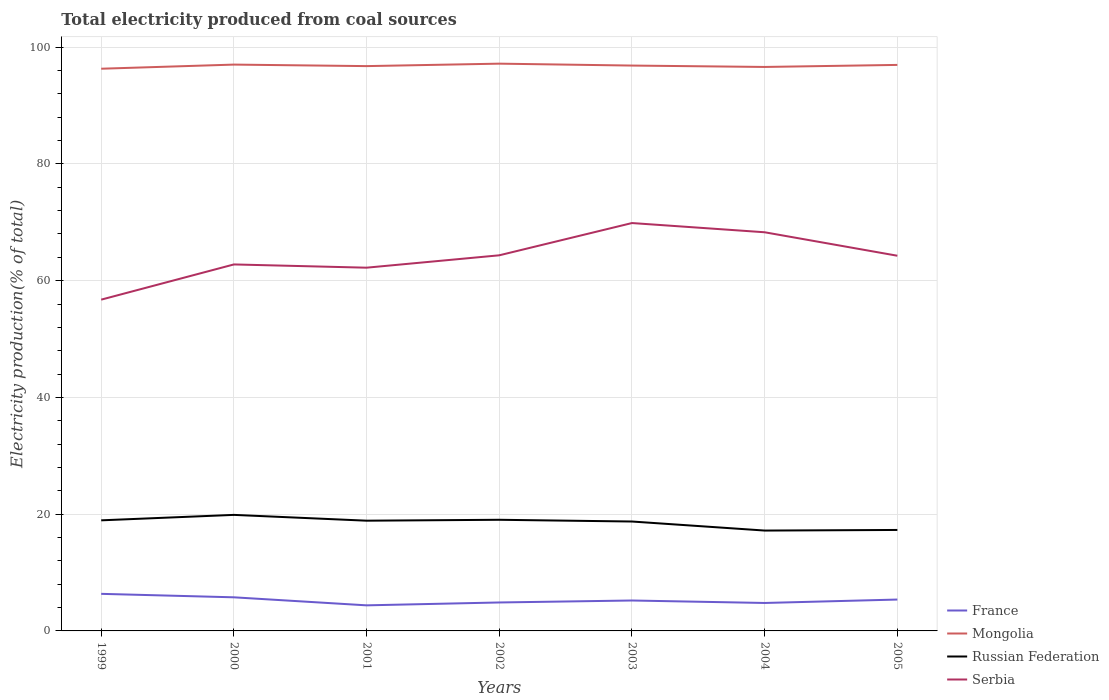How many different coloured lines are there?
Your response must be concise. 4. Does the line corresponding to Mongolia intersect with the line corresponding to Russian Federation?
Make the answer very short. No. Is the number of lines equal to the number of legend labels?
Provide a short and direct response. Yes. Across all years, what is the maximum total electricity produced in Serbia?
Offer a terse response. 56.75. What is the total total electricity produced in France in the graph?
Give a very brief answer. -0.41. What is the difference between the highest and the second highest total electricity produced in Serbia?
Your answer should be very brief. 13.12. How many lines are there?
Offer a very short reply. 4. How many years are there in the graph?
Provide a short and direct response. 7. Does the graph contain any zero values?
Your answer should be very brief. No. How many legend labels are there?
Make the answer very short. 4. What is the title of the graph?
Offer a very short reply. Total electricity produced from coal sources. What is the label or title of the X-axis?
Make the answer very short. Years. What is the label or title of the Y-axis?
Provide a succinct answer. Electricity production(% of total). What is the Electricity production(% of total) in France in 1999?
Give a very brief answer. 6.35. What is the Electricity production(% of total) of Mongolia in 1999?
Your answer should be very brief. 96.31. What is the Electricity production(% of total) of Russian Federation in 1999?
Make the answer very short. 18.94. What is the Electricity production(% of total) of Serbia in 1999?
Ensure brevity in your answer.  56.75. What is the Electricity production(% of total) of France in 2000?
Your answer should be very brief. 5.76. What is the Electricity production(% of total) of Mongolia in 2000?
Provide a succinct answer. 97.01. What is the Electricity production(% of total) of Russian Federation in 2000?
Ensure brevity in your answer.  19.88. What is the Electricity production(% of total) in Serbia in 2000?
Your answer should be compact. 62.78. What is the Electricity production(% of total) of France in 2001?
Offer a very short reply. 4.38. What is the Electricity production(% of total) in Mongolia in 2001?
Your answer should be compact. 96.75. What is the Electricity production(% of total) of Russian Federation in 2001?
Your answer should be very brief. 18.88. What is the Electricity production(% of total) in Serbia in 2001?
Provide a succinct answer. 62.22. What is the Electricity production(% of total) in France in 2002?
Ensure brevity in your answer.  4.87. What is the Electricity production(% of total) of Mongolia in 2002?
Keep it short and to the point. 97.17. What is the Electricity production(% of total) of Russian Federation in 2002?
Give a very brief answer. 19.04. What is the Electricity production(% of total) in Serbia in 2002?
Ensure brevity in your answer.  64.34. What is the Electricity production(% of total) of France in 2003?
Offer a terse response. 5.21. What is the Electricity production(% of total) in Mongolia in 2003?
Give a very brief answer. 96.85. What is the Electricity production(% of total) of Russian Federation in 2003?
Provide a succinct answer. 18.74. What is the Electricity production(% of total) of Serbia in 2003?
Give a very brief answer. 69.87. What is the Electricity production(% of total) of France in 2004?
Ensure brevity in your answer.  4.79. What is the Electricity production(% of total) of Mongolia in 2004?
Make the answer very short. 96.61. What is the Electricity production(% of total) of Russian Federation in 2004?
Give a very brief answer. 17.19. What is the Electricity production(% of total) in Serbia in 2004?
Provide a short and direct response. 68.29. What is the Electricity production(% of total) of France in 2005?
Your answer should be very brief. 5.37. What is the Electricity production(% of total) of Mongolia in 2005?
Offer a very short reply. 96.96. What is the Electricity production(% of total) in Russian Federation in 2005?
Your answer should be very brief. 17.3. What is the Electricity production(% of total) of Serbia in 2005?
Keep it short and to the point. 64.27. Across all years, what is the maximum Electricity production(% of total) in France?
Offer a very short reply. 6.35. Across all years, what is the maximum Electricity production(% of total) in Mongolia?
Give a very brief answer. 97.17. Across all years, what is the maximum Electricity production(% of total) in Russian Federation?
Offer a very short reply. 19.88. Across all years, what is the maximum Electricity production(% of total) of Serbia?
Offer a very short reply. 69.87. Across all years, what is the minimum Electricity production(% of total) in France?
Give a very brief answer. 4.38. Across all years, what is the minimum Electricity production(% of total) of Mongolia?
Keep it short and to the point. 96.31. Across all years, what is the minimum Electricity production(% of total) in Russian Federation?
Keep it short and to the point. 17.19. Across all years, what is the minimum Electricity production(% of total) of Serbia?
Give a very brief answer. 56.75. What is the total Electricity production(% of total) in France in the graph?
Give a very brief answer. 36.74. What is the total Electricity production(% of total) in Mongolia in the graph?
Keep it short and to the point. 677.65. What is the total Electricity production(% of total) of Russian Federation in the graph?
Your response must be concise. 129.97. What is the total Electricity production(% of total) of Serbia in the graph?
Your response must be concise. 448.53. What is the difference between the Electricity production(% of total) of France in 1999 and that in 2000?
Provide a short and direct response. 0.59. What is the difference between the Electricity production(% of total) of Mongolia in 1999 and that in 2000?
Offer a terse response. -0.71. What is the difference between the Electricity production(% of total) in Russian Federation in 1999 and that in 2000?
Offer a terse response. -0.93. What is the difference between the Electricity production(% of total) of Serbia in 1999 and that in 2000?
Ensure brevity in your answer.  -6.03. What is the difference between the Electricity production(% of total) of France in 1999 and that in 2001?
Keep it short and to the point. 1.97. What is the difference between the Electricity production(% of total) of Mongolia in 1999 and that in 2001?
Provide a succinct answer. -0.45. What is the difference between the Electricity production(% of total) of Russian Federation in 1999 and that in 2001?
Your answer should be compact. 0.06. What is the difference between the Electricity production(% of total) of Serbia in 1999 and that in 2001?
Your response must be concise. -5.47. What is the difference between the Electricity production(% of total) of France in 1999 and that in 2002?
Provide a succinct answer. 1.48. What is the difference between the Electricity production(% of total) of Mongolia in 1999 and that in 2002?
Ensure brevity in your answer.  -0.87. What is the difference between the Electricity production(% of total) of Russian Federation in 1999 and that in 2002?
Your answer should be compact. -0.09. What is the difference between the Electricity production(% of total) in Serbia in 1999 and that in 2002?
Your answer should be very brief. -7.59. What is the difference between the Electricity production(% of total) of France in 1999 and that in 2003?
Provide a short and direct response. 1.14. What is the difference between the Electricity production(% of total) in Mongolia in 1999 and that in 2003?
Your answer should be very brief. -0.54. What is the difference between the Electricity production(% of total) of Russian Federation in 1999 and that in 2003?
Provide a short and direct response. 0.2. What is the difference between the Electricity production(% of total) in Serbia in 1999 and that in 2003?
Offer a terse response. -13.12. What is the difference between the Electricity production(% of total) of France in 1999 and that in 2004?
Ensure brevity in your answer.  1.57. What is the difference between the Electricity production(% of total) in Mongolia in 1999 and that in 2004?
Provide a short and direct response. -0.3. What is the difference between the Electricity production(% of total) in Russian Federation in 1999 and that in 2004?
Your answer should be compact. 1.75. What is the difference between the Electricity production(% of total) of Serbia in 1999 and that in 2004?
Give a very brief answer. -11.54. What is the difference between the Electricity production(% of total) of France in 1999 and that in 2005?
Offer a terse response. 0.98. What is the difference between the Electricity production(% of total) of Mongolia in 1999 and that in 2005?
Offer a terse response. -0.65. What is the difference between the Electricity production(% of total) in Russian Federation in 1999 and that in 2005?
Offer a very short reply. 1.65. What is the difference between the Electricity production(% of total) in Serbia in 1999 and that in 2005?
Your answer should be compact. -7.52. What is the difference between the Electricity production(% of total) of France in 2000 and that in 2001?
Make the answer very short. 1.38. What is the difference between the Electricity production(% of total) of Mongolia in 2000 and that in 2001?
Offer a terse response. 0.26. What is the difference between the Electricity production(% of total) in Russian Federation in 2000 and that in 2001?
Your answer should be very brief. 1. What is the difference between the Electricity production(% of total) of Serbia in 2000 and that in 2001?
Provide a short and direct response. 0.56. What is the difference between the Electricity production(% of total) of France in 2000 and that in 2002?
Make the answer very short. 0.88. What is the difference between the Electricity production(% of total) of Mongolia in 2000 and that in 2002?
Keep it short and to the point. -0.16. What is the difference between the Electricity production(% of total) in Russian Federation in 2000 and that in 2002?
Your response must be concise. 0.84. What is the difference between the Electricity production(% of total) of Serbia in 2000 and that in 2002?
Offer a terse response. -1.56. What is the difference between the Electricity production(% of total) of France in 2000 and that in 2003?
Give a very brief answer. 0.55. What is the difference between the Electricity production(% of total) in Mongolia in 2000 and that in 2003?
Provide a succinct answer. 0.17. What is the difference between the Electricity production(% of total) of Russian Federation in 2000 and that in 2003?
Offer a very short reply. 1.14. What is the difference between the Electricity production(% of total) of Serbia in 2000 and that in 2003?
Offer a very short reply. -7.09. What is the difference between the Electricity production(% of total) of France in 2000 and that in 2004?
Your answer should be very brief. 0.97. What is the difference between the Electricity production(% of total) of Mongolia in 2000 and that in 2004?
Your answer should be compact. 0.4. What is the difference between the Electricity production(% of total) in Russian Federation in 2000 and that in 2004?
Keep it short and to the point. 2.68. What is the difference between the Electricity production(% of total) in Serbia in 2000 and that in 2004?
Provide a succinct answer. -5.51. What is the difference between the Electricity production(% of total) of France in 2000 and that in 2005?
Offer a terse response. 0.38. What is the difference between the Electricity production(% of total) of Mongolia in 2000 and that in 2005?
Keep it short and to the point. 0.05. What is the difference between the Electricity production(% of total) of Russian Federation in 2000 and that in 2005?
Make the answer very short. 2.58. What is the difference between the Electricity production(% of total) in Serbia in 2000 and that in 2005?
Your answer should be compact. -1.49. What is the difference between the Electricity production(% of total) in France in 2001 and that in 2002?
Your answer should be compact. -0.49. What is the difference between the Electricity production(% of total) in Mongolia in 2001 and that in 2002?
Give a very brief answer. -0.42. What is the difference between the Electricity production(% of total) of Russian Federation in 2001 and that in 2002?
Make the answer very short. -0.16. What is the difference between the Electricity production(% of total) of Serbia in 2001 and that in 2002?
Your answer should be compact. -2.12. What is the difference between the Electricity production(% of total) in France in 2001 and that in 2003?
Give a very brief answer. -0.83. What is the difference between the Electricity production(% of total) in Mongolia in 2001 and that in 2003?
Provide a succinct answer. -0.09. What is the difference between the Electricity production(% of total) in Russian Federation in 2001 and that in 2003?
Your answer should be very brief. 0.14. What is the difference between the Electricity production(% of total) in Serbia in 2001 and that in 2003?
Your answer should be compact. -7.65. What is the difference between the Electricity production(% of total) of France in 2001 and that in 2004?
Give a very brief answer. -0.41. What is the difference between the Electricity production(% of total) of Mongolia in 2001 and that in 2004?
Your answer should be very brief. 0.14. What is the difference between the Electricity production(% of total) of Russian Federation in 2001 and that in 2004?
Provide a succinct answer. 1.69. What is the difference between the Electricity production(% of total) in Serbia in 2001 and that in 2004?
Your response must be concise. -6.07. What is the difference between the Electricity production(% of total) of France in 2001 and that in 2005?
Give a very brief answer. -0.99. What is the difference between the Electricity production(% of total) in Mongolia in 2001 and that in 2005?
Your response must be concise. -0.21. What is the difference between the Electricity production(% of total) of Russian Federation in 2001 and that in 2005?
Offer a terse response. 1.59. What is the difference between the Electricity production(% of total) of Serbia in 2001 and that in 2005?
Provide a short and direct response. -2.05. What is the difference between the Electricity production(% of total) in France in 2002 and that in 2003?
Your response must be concise. -0.34. What is the difference between the Electricity production(% of total) in Mongolia in 2002 and that in 2003?
Provide a succinct answer. 0.33. What is the difference between the Electricity production(% of total) of Russian Federation in 2002 and that in 2003?
Your answer should be compact. 0.3. What is the difference between the Electricity production(% of total) of Serbia in 2002 and that in 2003?
Offer a very short reply. -5.53. What is the difference between the Electricity production(% of total) in France in 2002 and that in 2004?
Offer a terse response. 0.09. What is the difference between the Electricity production(% of total) in Mongolia in 2002 and that in 2004?
Offer a very short reply. 0.56. What is the difference between the Electricity production(% of total) of Russian Federation in 2002 and that in 2004?
Give a very brief answer. 1.85. What is the difference between the Electricity production(% of total) in Serbia in 2002 and that in 2004?
Offer a very short reply. -3.95. What is the difference between the Electricity production(% of total) of France in 2002 and that in 2005?
Give a very brief answer. -0.5. What is the difference between the Electricity production(% of total) in Mongolia in 2002 and that in 2005?
Ensure brevity in your answer.  0.21. What is the difference between the Electricity production(% of total) in Russian Federation in 2002 and that in 2005?
Ensure brevity in your answer.  1.74. What is the difference between the Electricity production(% of total) of Serbia in 2002 and that in 2005?
Provide a succinct answer. 0.07. What is the difference between the Electricity production(% of total) in France in 2003 and that in 2004?
Your answer should be very brief. 0.42. What is the difference between the Electricity production(% of total) of Mongolia in 2003 and that in 2004?
Your answer should be very brief. 0.24. What is the difference between the Electricity production(% of total) of Russian Federation in 2003 and that in 2004?
Your answer should be very brief. 1.55. What is the difference between the Electricity production(% of total) of Serbia in 2003 and that in 2004?
Keep it short and to the point. 1.58. What is the difference between the Electricity production(% of total) of France in 2003 and that in 2005?
Ensure brevity in your answer.  -0.16. What is the difference between the Electricity production(% of total) of Mongolia in 2003 and that in 2005?
Give a very brief answer. -0.11. What is the difference between the Electricity production(% of total) of Russian Federation in 2003 and that in 2005?
Provide a short and direct response. 1.45. What is the difference between the Electricity production(% of total) in Serbia in 2003 and that in 2005?
Offer a very short reply. 5.6. What is the difference between the Electricity production(% of total) in France in 2004 and that in 2005?
Provide a short and direct response. -0.59. What is the difference between the Electricity production(% of total) in Mongolia in 2004 and that in 2005?
Make the answer very short. -0.35. What is the difference between the Electricity production(% of total) in Russian Federation in 2004 and that in 2005?
Provide a succinct answer. -0.1. What is the difference between the Electricity production(% of total) in Serbia in 2004 and that in 2005?
Keep it short and to the point. 4.02. What is the difference between the Electricity production(% of total) of France in 1999 and the Electricity production(% of total) of Mongolia in 2000?
Offer a very short reply. -90.66. What is the difference between the Electricity production(% of total) of France in 1999 and the Electricity production(% of total) of Russian Federation in 2000?
Offer a terse response. -13.52. What is the difference between the Electricity production(% of total) of France in 1999 and the Electricity production(% of total) of Serbia in 2000?
Ensure brevity in your answer.  -56.43. What is the difference between the Electricity production(% of total) of Mongolia in 1999 and the Electricity production(% of total) of Russian Federation in 2000?
Give a very brief answer. 76.43. What is the difference between the Electricity production(% of total) of Mongolia in 1999 and the Electricity production(% of total) of Serbia in 2000?
Your response must be concise. 33.53. What is the difference between the Electricity production(% of total) of Russian Federation in 1999 and the Electricity production(% of total) of Serbia in 2000?
Keep it short and to the point. -43.84. What is the difference between the Electricity production(% of total) of France in 1999 and the Electricity production(% of total) of Mongolia in 2001?
Provide a succinct answer. -90.4. What is the difference between the Electricity production(% of total) in France in 1999 and the Electricity production(% of total) in Russian Federation in 2001?
Ensure brevity in your answer.  -12.53. What is the difference between the Electricity production(% of total) in France in 1999 and the Electricity production(% of total) in Serbia in 2001?
Offer a very short reply. -55.87. What is the difference between the Electricity production(% of total) of Mongolia in 1999 and the Electricity production(% of total) of Russian Federation in 2001?
Keep it short and to the point. 77.42. What is the difference between the Electricity production(% of total) in Mongolia in 1999 and the Electricity production(% of total) in Serbia in 2001?
Give a very brief answer. 34.08. What is the difference between the Electricity production(% of total) in Russian Federation in 1999 and the Electricity production(% of total) in Serbia in 2001?
Give a very brief answer. -43.28. What is the difference between the Electricity production(% of total) of France in 1999 and the Electricity production(% of total) of Mongolia in 2002?
Provide a short and direct response. -90.82. What is the difference between the Electricity production(% of total) of France in 1999 and the Electricity production(% of total) of Russian Federation in 2002?
Your response must be concise. -12.69. What is the difference between the Electricity production(% of total) in France in 1999 and the Electricity production(% of total) in Serbia in 2002?
Provide a short and direct response. -57.99. What is the difference between the Electricity production(% of total) of Mongolia in 1999 and the Electricity production(% of total) of Russian Federation in 2002?
Make the answer very short. 77.27. What is the difference between the Electricity production(% of total) in Mongolia in 1999 and the Electricity production(% of total) in Serbia in 2002?
Your answer should be compact. 31.96. What is the difference between the Electricity production(% of total) of Russian Federation in 1999 and the Electricity production(% of total) of Serbia in 2002?
Keep it short and to the point. -45.4. What is the difference between the Electricity production(% of total) in France in 1999 and the Electricity production(% of total) in Mongolia in 2003?
Make the answer very short. -90.49. What is the difference between the Electricity production(% of total) in France in 1999 and the Electricity production(% of total) in Russian Federation in 2003?
Ensure brevity in your answer.  -12.39. What is the difference between the Electricity production(% of total) of France in 1999 and the Electricity production(% of total) of Serbia in 2003?
Provide a succinct answer. -63.52. What is the difference between the Electricity production(% of total) in Mongolia in 1999 and the Electricity production(% of total) in Russian Federation in 2003?
Provide a short and direct response. 77.56. What is the difference between the Electricity production(% of total) of Mongolia in 1999 and the Electricity production(% of total) of Serbia in 2003?
Ensure brevity in your answer.  26.44. What is the difference between the Electricity production(% of total) in Russian Federation in 1999 and the Electricity production(% of total) in Serbia in 2003?
Offer a very short reply. -50.92. What is the difference between the Electricity production(% of total) in France in 1999 and the Electricity production(% of total) in Mongolia in 2004?
Give a very brief answer. -90.26. What is the difference between the Electricity production(% of total) of France in 1999 and the Electricity production(% of total) of Russian Federation in 2004?
Your response must be concise. -10.84. What is the difference between the Electricity production(% of total) of France in 1999 and the Electricity production(% of total) of Serbia in 2004?
Offer a terse response. -61.94. What is the difference between the Electricity production(% of total) of Mongolia in 1999 and the Electricity production(% of total) of Russian Federation in 2004?
Ensure brevity in your answer.  79.11. What is the difference between the Electricity production(% of total) of Mongolia in 1999 and the Electricity production(% of total) of Serbia in 2004?
Your response must be concise. 28.01. What is the difference between the Electricity production(% of total) in Russian Federation in 1999 and the Electricity production(% of total) in Serbia in 2004?
Your response must be concise. -49.35. What is the difference between the Electricity production(% of total) of France in 1999 and the Electricity production(% of total) of Mongolia in 2005?
Your answer should be very brief. -90.61. What is the difference between the Electricity production(% of total) of France in 1999 and the Electricity production(% of total) of Russian Federation in 2005?
Your answer should be compact. -10.94. What is the difference between the Electricity production(% of total) in France in 1999 and the Electricity production(% of total) in Serbia in 2005?
Ensure brevity in your answer.  -57.92. What is the difference between the Electricity production(% of total) of Mongolia in 1999 and the Electricity production(% of total) of Russian Federation in 2005?
Your answer should be compact. 79.01. What is the difference between the Electricity production(% of total) of Mongolia in 1999 and the Electricity production(% of total) of Serbia in 2005?
Your answer should be very brief. 32.03. What is the difference between the Electricity production(% of total) in Russian Federation in 1999 and the Electricity production(% of total) in Serbia in 2005?
Keep it short and to the point. -45.33. What is the difference between the Electricity production(% of total) in France in 2000 and the Electricity production(% of total) in Mongolia in 2001?
Ensure brevity in your answer.  -90.99. What is the difference between the Electricity production(% of total) of France in 2000 and the Electricity production(% of total) of Russian Federation in 2001?
Ensure brevity in your answer.  -13.12. What is the difference between the Electricity production(% of total) in France in 2000 and the Electricity production(% of total) in Serbia in 2001?
Provide a succinct answer. -56.47. What is the difference between the Electricity production(% of total) in Mongolia in 2000 and the Electricity production(% of total) in Russian Federation in 2001?
Give a very brief answer. 78.13. What is the difference between the Electricity production(% of total) of Mongolia in 2000 and the Electricity production(% of total) of Serbia in 2001?
Your answer should be compact. 34.79. What is the difference between the Electricity production(% of total) of Russian Federation in 2000 and the Electricity production(% of total) of Serbia in 2001?
Offer a very short reply. -42.35. What is the difference between the Electricity production(% of total) of France in 2000 and the Electricity production(% of total) of Mongolia in 2002?
Your answer should be very brief. -91.41. What is the difference between the Electricity production(% of total) of France in 2000 and the Electricity production(% of total) of Russian Federation in 2002?
Provide a short and direct response. -13.28. What is the difference between the Electricity production(% of total) of France in 2000 and the Electricity production(% of total) of Serbia in 2002?
Keep it short and to the point. -58.59. What is the difference between the Electricity production(% of total) of Mongolia in 2000 and the Electricity production(% of total) of Russian Federation in 2002?
Offer a very short reply. 77.97. What is the difference between the Electricity production(% of total) of Mongolia in 2000 and the Electricity production(% of total) of Serbia in 2002?
Your answer should be very brief. 32.67. What is the difference between the Electricity production(% of total) of Russian Federation in 2000 and the Electricity production(% of total) of Serbia in 2002?
Offer a very short reply. -44.47. What is the difference between the Electricity production(% of total) of France in 2000 and the Electricity production(% of total) of Mongolia in 2003?
Your answer should be very brief. -91.09. What is the difference between the Electricity production(% of total) in France in 2000 and the Electricity production(% of total) in Russian Federation in 2003?
Offer a very short reply. -12.98. What is the difference between the Electricity production(% of total) of France in 2000 and the Electricity production(% of total) of Serbia in 2003?
Offer a terse response. -64.11. What is the difference between the Electricity production(% of total) of Mongolia in 2000 and the Electricity production(% of total) of Russian Federation in 2003?
Your answer should be compact. 78.27. What is the difference between the Electricity production(% of total) in Mongolia in 2000 and the Electricity production(% of total) in Serbia in 2003?
Give a very brief answer. 27.14. What is the difference between the Electricity production(% of total) of Russian Federation in 2000 and the Electricity production(% of total) of Serbia in 2003?
Ensure brevity in your answer.  -49.99. What is the difference between the Electricity production(% of total) in France in 2000 and the Electricity production(% of total) in Mongolia in 2004?
Make the answer very short. -90.85. What is the difference between the Electricity production(% of total) of France in 2000 and the Electricity production(% of total) of Russian Federation in 2004?
Offer a terse response. -11.44. What is the difference between the Electricity production(% of total) of France in 2000 and the Electricity production(% of total) of Serbia in 2004?
Make the answer very short. -62.53. What is the difference between the Electricity production(% of total) in Mongolia in 2000 and the Electricity production(% of total) in Russian Federation in 2004?
Your response must be concise. 79.82. What is the difference between the Electricity production(% of total) of Mongolia in 2000 and the Electricity production(% of total) of Serbia in 2004?
Provide a short and direct response. 28.72. What is the difference between the Electricity production(% of total) in Russian Federation in 2000 and the Electricity production(% of total) in Serbia in 2004?
Make the answer very short. -48.41. What is the difference between the Electricity production(% of total) in France in 2000 and the Electricity production(% of total) in Mongolia in 2005?
Offer a very short reply. -91.2. What is the difference between the Electricity production(% of total) of France in 2000 and the Electricity production(% of total) of Russian Federation in 2005?
Offer a very short reply. -11.54. What is the difference between the Electricity production(% of total) of France in 2000 and the Electricity production(% of total) of Serbia in 2005?
Your response must be concise. -58.51. What is the difference between the Electricity production(% of total) in Mongolia in 2000 and the Electricity production(% of total) in Russian Federation in 2005?
Make the answer very short. 79.72. What is the difference between the Electricity production(% of total) of Mongolia in 2000 and the Electricity production(% of total) of Serbia in 2005?
Ensure brevity in your answer.  32.74. What is the difference between the Electricity production(% of total) in Russian Federation in 2000 and the Electricity production(% of total) in Serbia in 2005?
Provide a short and direct response. -44.39. What is the difference between the Electricity production(% of total) in France in 2001 and the Electricity production(% of total) in Mongolia in 2002?
Provide a succinct answer. -92.79. What is the difference between the Electricity production(% of total) of France in 2001 and the Electricity production(% of total) of Russian Federation in 2002?
Your response must be concise. -14.66. What is the difference between the Electricity production(% of total) of France in 2001 and the Electricity production(% of total) of Serbia in 2002?
Make the answer very short. -59.96. What is the difference between the Electricity production(% of total) in Mongolia in 2001 and the Electricity production(% of total) in Russian Federation in 2002?
Provide a succinct answer. 77.71. What is the difference between the Electricity production(% of total) in Mongolia in 2001 and the Electricity production(% of total) in Serbia in 2002?
Offer a very short reply. 32.41. What is the difference between the Electricity production(% of total) of Russian Federation in 2001 and the Electricity production(% of total) of Serbia in 2002?
Offer a very short reply. -45.46. What is the difference between the Electricity production(% of total) in France in 2001 and the Electricity production(% of total) in Mongolia in 2003?
Provide a short and direct response. -92.46. What is the difference between the Electricity production(% of total) in France in 2001 and the Electricity production(% of total) in Russian Federation in 2003?
Keep it short and to the point. -14.36. What is the difference between the Electricity production(% of total) of France in 2001 and the Electricity production(% of total) of Serbia in 2003?
Offer a very short reply. -65.49. What is the difference between the Electricity production(% of total) in Mongolia in 2001 and the Electricity production(% of total) in Russian Federation in 2003?
Provide a short and direct response. 78.01. What is the difference between the Electricity production(% of total) of Mongolia in 2001 and the Electricity production(% of total) of Serbia in 2003?
Ensure brevity in your answer.  26.88. What is the difference between the Electricity production(% of total) of Russian Federation in 2001 and the Electricity production(% of total) of Serbia in 2003?
Provide a succinct answer. -50.99. What is the difference between the Electricity production(% of total) of France in 2001 and the Electricity production(% of total) of Mongolia in 2004?
Provide a succinct answer. -92.23. What is the difference between the Electricity production(% of total) of France in 2001 and the Electricity production(% of total) of Russian Federation in 2004?
Ensure brevity in your answer.  -12.81. What is the difference between the Electricity production(% of total) of France in 2001 and the Electricity production(% of total) of Serbia in 2004?
Offer a very short reply. -63.91. What is the difference between the Electricity production(% of total) in Mongolia in 2001 and the Electricity production(% of total) in Russian Federation in 2004?
Offer a terse response. 79.56. What is the difference between the Electricity production(% of total) of Mongolia in 2001 and the Electricity production(% of total) of Serbia in 2004?
Provide a short and direct response. 28.46. What is the difference between the Electricity production(% of total) of Russian Federation in 2001 and the Electricity production(% of total) of Serbia in 2004?
Make the answer very short. -49.41. What is the difference between the Electricity production(% of total) in France in 2001 and the Electricity production(% of total) in Mongolia in 2005?
Ensure brevity in your answer.  -92.58. What is the difference between the Electricity production(% of total) of France in 2001 and the Electricity production(% of total) of Russian Federation in 2005?
Give a very brief answer. -12.91. What is the difference between the Electricity production(% of total) of France in 2001 and the Electricity production(% of total) of Serbia in 2005?
Provide a short and direct response. -59.89. What is the difference between the Electricity production(% of total) in Mongolia in 2001 and the Electricity production(% of total) in Russian Federation in 2005?
Make the answer very short. 79.46. What is the difference between the Electricity production(% of total) in Mongolia in 2001 and the Electricity production(% of total) in Serbia in 2005?
Your answer should be compact. 32.48. What is the difference between the Electricity production(% of total) of Russian Federation in 2001 and the Electricity production(% of total) of Serbia in 2005?
Provide a short and direct response. -45.39. What is the difference between the Electricity production(% of total) of France in 2002 and the Electricity production(% of total) of Mongolia in 2003?
Offer a very short reply. -91.97. What is the difference between the Electricity production(% of total) in France in 2002 and the Electricity production(% of total) in Russian Federation in 2003?
Your answer should be compact. -13.87. What is the difference between the Electricity production(% of total) in France in 2002 and the Electricity production(% of total) in Serbia in 2003?
Ensure brevity in your answer.  -65. What is the difference between the Electricity production(% of total) in Mongolia in 2002 and the Electricity production(% of total) in Russian Federation in 2003?
Your answer should be compact. 78.43. What is the difference between the Electricity production(% of total) of Mongolia in 2002 and the Electricity production(% of total) of Serbia in 2003?
Give a very brief answer. 27.3. What is the difference between the Electricity production(% of total) in Russian Federation in 2002 and the Electricity production(% of total) in Serbia in 2003?
Your answer should be compact. -50.83. What is the difference between the Electricity production(% of total) in France in 2002 and the Electricity production(% of total) in Mongolia in 2004?
Offer a terse response. -91.74. What is the difference between the Electricity production(% of total) in France in 2002 and the Electricity production(% of total) in Russian Federation in 2004?
Provide a short and direct response. -12.32. What is the difference between the Electricity production(% of total) of France in 2002 and the Electricity production(% of total) of Serbia in 2004?
Provide a succinct answer. -63.42. What is the difference between the Electricity production(% of total) in Mongolia in 2002 and the Electricity production(% of total) in Russian Federation in 2004?
Your response must be concise. 79.98. What is the difference between the Electricity production(% of total) in Mongolia in 2002 and the Electricity production(% of total) in Serbia in 2004?
Your answer should be very brief. 28.88. What is the difference between the Electricity production(% of total) of Russian Federation in 2002 and the Electricity production(% of total) of Serbia in 2004?
Keep it short and to the point. -49.25. What is the difference between the Electricity production(% of total) of France in 2002 and the Electricity production(% of total) of Mongolia in 2005?
Your answer should be very brief. -92.08. What is the difference between the Electricity production(% of total) in France in 2002 and the Electricity production(% of total) in Russian Federation in 2005?
Offer a terse response. -12.42. What is the difference between the Electricity production(% of total) of France in 2002 and the Electricity production(% of total) of Serbia in 2005?
Ensure brevity in your answer.  -59.4. What is the difference between the Electricity production(% of total) of Mongolia in 2002 and the Electricity production(% of total) of Russian Federation in 2005?
Your answer should be compact. 79.88. What is the difference between the Electricity production(% of total) of Mongolia in 2002 and the Electricity production(% of total) of Serbia in 2005?
Offer a terse response. 32.9. What is the difference between the Electricity production(% of total) in Russian Federation in 2002 and the Electricity production(% of total) in Serbia in 2005?
Provide a short and direct response. -45.23. What is the difference between the Electricity production(% of total) in France in 2003 and the Electricity production(% of total) in Mongolia in 2004?
Provide a short and direct response. -91.4. What is the difference between the Electricity production(% of total) of France in 2003 and the Electricity production(% of total) of Russian Federation in 2004?
Make the answer very short. -11.98. What is the difference between the Electricity production(% of total) in France in 2003 and the Electricity production(% of total) in Serbia in 2004?
Your answer should be compact. -63.08. What is the difference between the Electricity production(% of total) of Mongolia in 2003 and the Electricity production(% of total) of Russian Federation in 2004?
Keep it short and to the point. 79.65. What is the difference between the Electricity production(% of total) in Mongolia in 2003 and the Electricity production(% of total) in Serbia in 2004?
Keep it short and to the point. 28.55. What is the difference between the Electricity production(% of total) in Russian Federation in 2003 and the Electricity production(% of total) in Serbia in 2004?
Make the answer very short. -49.55. What is the difference between the Electricity production(% of total) in France in 2003 and the Electricity production(% of total) in Mongolia in 2005?
Your answer should be compact. -91.75. What is the difference between the Electricity production(% of total) in France in 2003 and the Electricity production(% of total) in Russian Federation in 2005?
Offer a very short reply. -12.08. What is the difference between the Electricity production(% of total) in France in 2003 and the Electricity production(% of total) in Serbia in 2005?
Make the answer very short. -59.06. What is the difference between the Electricity production(% of total) in Mongolia in 2003 and the Electricity production(% of total) in Russian Federation in 2005?
Offer a terse response. 79.55. What is the difference between the Electricity production(% of total) of Mongolia in 2003 and the Electricity production(% of total) of Serbia in 2005?
Offer a terse response. 32.57. What is the difference between the Electricity production(% of total) in Russian Federation in 2003 and the Electricity production(% of total) in Serbia in 2005?
Your response must be concise. -45.53. What is the difference between the Electricity production(% of total) of France in 2004 and the Electricity production(% of total) of Mongolia in 2005?
Ensure brevity in your answer.  -92.17. What is the difference between the Electricity production(% of total) in France in 2004 and the Electricity production(% of total) in Russian Federation in 2005?
Ensure brevity in your answer.  -12.51. What is the difference between the Electricity production(% of total) of France in 2004 and the Electricity production(% of total) of Serbia in 2005?
Give a very brief answer. -59.48. What is the difference between the Electricity production(% of total) of Mongolia in 2004 and the Electricity production(% of total) of Russian Federation in 2005?
Provide a short and direct response. 79.31. What is the difference between the Electricity production(% of total) in Mongolia in 2004 and the Electricity production(% of total) in Serbia in 2005?
Keep it short and to the point. 32.34. What is the difference between the Electricity production(% of total) of Russian Federation in 2004 and the Electricity production(% of total) of Serbia in 2005?
Provide a short and direct response. -47.08. What is the average Electricity production(% of total) of France per year?
Keep it short and to the point. 5.25. What is the average Electricity production(% of total) in Mongolia per year?
Make the answer very short. 96.81. What is the average Electricity production(% of total) of Russian Federation per year?
Provide a succinct answer. 18.57. What is the average Electricity production(% of total) in Serbia per year?
Offer a terse response. 64.08. In the year 1999, what is the difference between the Electricity production(% of total) of France and Electricity production(% of total) of Mongolia?
Your answer should be compact. -89.95. In the year 1999, what is the difference between the Electricity production(% of total) of France and Electricity production(% of total) of Russian Federation?
Keep it short and to the point. -12.59. In the year 1999, what is the difference between the Electricity production(% of total) of France and Electricity production(% of total) of Serbia?
Ensure brevity in your answer.  -50.4. In the year 1999, what is the difference between the Electricity production(% of total) in Mongolia and Electricity production(% of total) in Russian Federation?
Your answer should be very brief. 77.36. In the year 1999, what is the difference between the Electricity production(% of total) of Mongolia and Electricity production(% of total) of Serbia?
Offer a terse response. 39.56. In the year 1999, what is the difference between the Electricity production(% of total) of Russian Federation and Electricity production(% of total) of Serbia?
Give a very brief answer. -37.8. In the year 2000, what is the difference between the Electricity production(% of total) of France and Electricity production(% of total) of Mongolia?
Your answer should be very brief. -91.26. In the year 2000, what is the difference between the Electricity production(% of total) of France and Electricity production(% of total) of Russian Federation?
Keep it short and to the point. -14.12. In the year 2000, what is the difference between the Electricity production(% of total) in France and Electricity production(% of total) in Serbia?
Your answer should be compact. -57.02. In the year 2000, what is the difference between the Electricity production(% of total) in Mongolia and Electricity production(% of total) in Russian Federation?
Provide a succinct answer. 77.14. In the year 2000, what is the difference between the Electricity production(% of total) in Mongolia and Electricity production(% of total) in Serbia?
Your response must be concise. 34.23. In the year 2000, what is the difference between the Electricity production(% of total) in Russian Federation and Electricity production(% of total) in Serbia?
Provide a short and direct response. -42.9. In the year 2001, what is the difference between the Electricity production(% of total) in France and Electricity production(% of total) in Mongolia?
Offer a very short reply. -92.37. In the year 2001, what is the difference between the Electricity production(% of total) of France and Electricity production(% of total) of Russian Federation?
Provide a succinct answer. -14.5. In the year 2001, what is the difference between the Electricity production(% of total) in France and Electricity production(% of total) in Serbia?
Give a very brief answer. -57.84. In the year 2001, what is the difference between the Electricity production(% of total) of Mongolia and Electricity production(% of total) of Russian Federation?
Offer a terse response. 77.87. In the year 2001, what is the difference between the Electricity production(% of total) in Mongolia and Electricity production(% of total) in Serbia?
Offer a very short reply. 34.53. In the year 2001, what is the difference between the Electricity production(% of total) of Russian Federation and Electricity production(% of total) of Serbia?
Your response must be concise. -43.34. In the year 2002, what is the difference between the Electricity production(% of total) of France and Electricity production(% of total) of Mongolia?
Make the answer very short. -92.3. In the year 2002, what is the difference between the Electricity production(% of total) in France and Electricity production(% of total) in Russian Federation?
Offer a very short reply. -14.16. In the year 2002, what is the difference between the Electricity production(% of total) of France and Electricity production(% of total) of Serbia?
Give a very brief answer. -59.47. In the year 2002, what is the difference between the Electricity production(% of total) in Mongolia and Electricity production(% of total) in Russian Federation?
Offer a terse response. 78.13. In the year 2002, what is the difference between the Electricity production(% of total) of Mongolia and Electricity production(% of total) of Serbia?
Your answer should be very brief. 32.83. In the year 2002, what is the difference between the Electricity production(% of total) of Russian Federation and Electricity production(% of total) of Serbia?
Keep it short and to the point. -45.31. In the year 2003, what is the difference between the Electricity production(% of total) in France and Electricity production(% of total) in Mongolia?
Offer a very short reply. -91.63. In the year 2003, what is the difference between the Electricity production(% of total) in France and Electricity production(% of total) in Russian Federation?
Provide a short and direct response. -13.53. In the year 2003, what is the difference between the Electricity production(% of total) of France and Electricity production(% of total) of Serbia?
Provide a short and direct response. -64.66. In the year 2003, what is the difference between the Electricity production(% of total) in Mongolia and Electricity production(% of total) in Russian Federation?
Ensure brevity in your answer.  78.1. In the year 2003, what is the difference between the Electricity production(% of total) of Mongolia and Electricity production(% of total) of Serbia?
Your answer should be compact. 26.98. In the year 2003, what is the difference between the Electricity production(% of total) of Russian Federation and Electricity production(% of total) of Serbia?
Your response must be concise. -51.13. In the year 2004, what is the difference between the Electricity production(% of total) of France and Electricity production(% of total) of Mongolia?
Offer a terse response. -91.82. In the year 2004, what is the difference between the Electricity production(% of total) in France and Electricity production(% of total) in Russian Federation?
Provide a short and direct response. -12.41. In the year 2004, what is the difference between the Electricity production(% of total) in France and Electricity production(% of total) in Serbia?
Your answer should be compact. -63.5. In the year 2004, what is the difference between the Electricity production(% of total) of Mongolia and Electricity production(% of total) of Russian Federation?
Your response must be concise. 79.42. In the year 2004, what is the difference between the Electricity production(% of total) of Mongolia and Electricity production(% of total) of Serbia?
Offer a very short reply. 28.32. In the year 2004, what is the difference between the Electricity production(% of total) of Russian Federation and Electricity production(% of total) of Serbia?
Give a very brief answer. -51.1. In the year 2005, what is the difference between the Electricity production(% of total) in France and Electricity production(% of total) in Mongolia?
Offer a terse response. -91.58. In the year 2005, what is the difference between the Electricity production(% of total) of France and Electricity production(% of total) of Russian Federation?
Ensure brevity in your answer.  -11.92. In the year 2005, what is the difference between the Electricity production(% of total) of France and Electricity production(% of total) of Serbia?
Your answer should be very brief. -58.9. In the year 2005, what is the difference between the Electricity production(% of total) of Mongolia and Electricity production(% of total) of Russian Federation?
Your answer should be very brief. 79.66. In the year 2005, what is the difference between the Electricity production(% of total) in Mongolia and Electricity production(% of total) in Serbia?
Offer a very short reply. 32.69. In the year 2005, what is the difference between the Electricity production(% of total) of Russian Federation and Electricity production(% of total) of Serbia?
Your answer should be compact. -46.98. What is the ratio of the Electricity production(% of total) of France in 1999 to that in 2000?
Provide a succinct answer. 1.1. What is the ratio of the Electricity production(% of total) of Mongolia in 1999 to that in 2000?
Keep it short and to the point. 0.99. What is the ratio of the Electricity production(% of total) of Russian Federation in 1999 to that in 2000?
Provide a short and direct response. 0.95. What is the ratio of the Electricity production(% of total) of Serbia in 1999 to that in 2000?
Your answer should be very brief. 0.9. What is the ratio of the Electricity production(% of total) of France in 1999 to that in 2001?
Provide a short and direct response. 1.45. What is the ratio of the Electricity production(% of total) of Russian Federation in 1999 to that in 2001?
Offer a terse response. 1. What is the ratio of the Electricity production(% of total) in Serbia in 1999 to that in 2001?
Give a very brief answer. 0.91. What is the ratio of the Electricity production(% of total) of France in 1999 to that in 2002?
Give a very brief answer. 1.3. What is the ratio of the Electricity production(% of total) in Mongolia in 1999 to that in 2002?
Give a very brief answer. 0.99. What is the ratio of the Electricity production(% of total) in Russian Federation in 1999 to that in 2002?
Your answer should be compact. 1. What is the ratio of the Electricity production(% of total) in Serbia in 1999 to that in 2002?
Give a very brief answer. 0.88. What is the ratio of the Electricity production(% of total) in France in 1999 to that in 2003?
Offer a terse response. 1.22. What is the ratio of the Electricity production(% of total) in Russian Federation in 1999 to that in 2003?
Ensure brevity in your answer.  1.01. What is the ratio of the Electricity production(% of total) of Serbia in 1999 to that in 2003?
Make the answer very short. 0.81. What is the ratio of the Electricity production(% of total) of France in 1999 to that in 2004?
Ensure brevity in your answer.  1.33. What is the ratio of the Electricity production(% of total) in Mongolia in 1999 to that in 2004?
Offer a terse response. 1. What is the ratio of the Electricity production(% of total) in Russian Federation in 1999 to that in 2004?
Give a very brief answer. 1.1. What is the ratio of the Electricity production(% of total) of Serbia in 1999 to that in 2004?
Your response must be concise. 0.83. What is the ratio of the Electricity production(% of total) of France in 1999 to that in 2005?
Your response must be concise. 1.18. What is the ratio of the Electricity production(% of total) of Mongolia in 1999 to that in 2005?
Offer a very short reply. 0.99. What is the ratio of the Electricity production(% of total) of Russian Federation in 1999 to that in 2005?
Provide a short and direct response. 1.1. What is the ratio of the Electricity production(% of total) of Serbia in 1999 to that in 2005?
Your answer should be very brief. 0.88. What is the ratio of the Electricity production(% of total) in France in 2000 to that in 2001?
Provide a short and direct response. 1.31. What is the ratio of the Electricity production(% of total) of Mongolia in 2000 to that in 2001?
Your answer should be very brief. 1. What is the ratio of the Electricity production(% of total) in Russian Federation in 2000 to that in 2001?
Your answer should be compact. 1.05. What is the ratio of the Electricity production(% of total) of Serbia in 2000 to that in 2001?
Ensure brevity in your answer.  1.01. What is the ratio of the Electricity production(% of total) of France in 2000 to that in 2002?
Keep it short and to the point. 1.18. What is the ratio of the Electricity production(% of total) in Russian Federation in 2000 to that in 2002?
Your answer should be compact. 1.04. What is the ratio of the Electricity production(% of total) of Serbia in 2000 to that in 2002?
Offer a very short reply. 0.98. What is the ratio of the Electricity production(% of total) in France in 2000 to that in 2003?
Your answer should be compact. 1.1. What is the ratio of the Electricity production(% of total) in Mongolia in 2000 to that in 2003?
Provide a succinct answer. 1. What is the ratio of the Electricity production(% of total) in Russian Federation in 2000 to that in 2003?
Keep it short and to the point. 1.06. What is the ratio of the Electricity production(% of total) in Serbia in 2000 to that in 2003?
Ensure brevity in your answer.  0.9. What is the ratio of the Electricity production(% of total) of France in 2000 to that in 2004?
Offer a very short reply. 1.2. What is the ratio of the Electricity production(% of total) in Mongolia in 2000 to that in 2004?
Your answer should be compact. 1. What is the ratio of the Electricity production(% of total) of Russian Federation in 2000 to that in 2004?
Make the answer very short. 1.16. What is the ratio of the Electricity production(% of total) in Serbia in 2000 to that in 2004?
Offer a very short reply. 0.92. What is the ratio of the Electricity production(% of total) in France in 2000 to that in 2005?
Ensure brevity in your answer.  1.07. What is the ratio of the Electricity production(% of total) in Mongolia in 2000 to that in 2005?
Your answer should be compact. 1. What is the ratio of the Electricity production(% of total) in Russian Federation in 2000 to that in 2005?
Keep it short and to the point. 1.15. What is the ratio of the Electricity production(% of total) of Serbia in 2000 to that in 2005?
Your answer should be very brief. 0.98. What is the ratio of the Electricity production(% of total) of France in 2001 to that in 2002?
Ensure brevity in your answer.  0.9. What is the ratio of the Electricity production(% of total) in Russian Federation in 2001 to that in 2002?
Make the answer very short. 0.99. What is the ratio of the Electricity production(% of total) of Serbia in 2001 to that in 2002?
Provide a succinct answer. 0.97. What is the ratio of the Electricity production(% of total) of France in 2001 to that in 2003?
Provide a succinct answer. 0.84. What is the ratio of the Electricity production(% of total) in Mongolia in 2001 to that in 2003?
Provide a succinct answer. 1. What is the ratio of the Electricity production(% of total) in Russian Federation in 2001 to that in 2003?
Provide a succinct answer. 1.01. What is the ratio of the Electricity production(% of total) of Serbia in 2001 to that in 2003?
Offer a terse response. 0.89. What is the ratio of the Electricity production(% of total) in France in 2001 to that in 2004?
Provide a succinct answer. 0.92. What is the ratio of the Electricity production(% of total) of Russian Federation in 2001 to that in 2004?
Offer a terse response. 1.1. What is the ratio of the Electricity production(% of total) in Serbia in 2001 to that in 2004?
Your answer should be very brief. 0.91. What is the ratio of the Electricity production(% of total) of France in 2001 to that in 2005?
Provide a short and direct response. 0.82. What is the ratio of the Electricity production(% of total) of Russian Federation in 2001 to that in 2005?
Ensure brevity in your answer.  1.09. What is the ratio of the Electricity production(% of total) in Serbia in 2001 to that in 2005?
Offer a terse response. 0.97. What is the ratio of the Electricity production(% of total) in France in 2002 to that in 2003?
Your response must be concise. 0.94. What is the ratio of the Electricity production(% of total) in Mongolia in 2002 to that in 2003?
Ensure brevity in your answer.  1. What is the ratio of the Electricity production(% of total) in Russian Federation in 2002 to that in 2003?
Your answer should be compact. 1.02. What is the ratio of the Electricity production(% of total) of Serbia in 2002 to that in 2003?
Give a very brief answer. 0.92. What is the ratio of the Electricity production(% of total) of France in 2002 to that in 2004?
Give a very brief answer. 1.02. What is the ratio of the Electricity production(% of total) of Russian Federation in 2002 to that in 2004?
Your answer should be very brief. 1.11. What is the ratio of the Electricity production(% of total) of Serbia in 2002 to that in 2004?
Ensure brevity in your answer.  0.94. What is the ratio of the Electricity production(% of total) of France in 2002 to that in 2005?
Provide a short and direct response. 0.91. What is the ratio of the Electricity production(% of total) of Russian Federation in 2002 to that in 2005?
Your answer should be very brief. 1.1. What is the ratio of the Electricity production(% of total) of Serbia in 2002 to that in 2005?
Provide a short and direct response. 1. What is the ratio of the Electricity production(% of total) in France in 2003 to that in 2004?
Keep it short and to the point. 1.09. What is the ratio of the Electricity production(% of total) of Mongolia in 2003 to that in 2004?
Offer a very short reply. 1. What is the ratio of the Electricity production(% of total) in Russian Federation in 2003 to that in 2004?
Offer a terse response. 1.09. What is the ratio of the Electricity production(% of total) in Serbia in 2003 to that in 2004?
Offer a very short reply. 1.02. What is the ratio of the Electricity production(% of total) in France in 2003 to that in 2005?
Offer a terse response. 0.97. What is the ratio of the Electricity production(% of total) of Russian Federation in 2003 to that in 2005?
Make the answer very short. 1.08. What is the ratio of the Electricity production(% of total) in Serbia in 2003 to that in 2005?
Your response must be concise. 1.09. What is the ratio of the Electricity production(% of total) of France in 2004 to that in 2005?
Your response must be concise. 0.89. What is the ratio of the Electricity production(% of total) in Mongolia in 2004 to that in 2005?
Make the answer very short. 1. What is the ratio of the Electricity production(% of total) of Russian Federation in 2004 to that in 2005?
Your answer should be compact. 0.99. What is the ratio of the Electricity production(% of total) of Serbia in 2004 to that in 2005?
Offer a very short reply. 1.06. What is the difference between the highest and the second highest Electricity production(% of total) of France?
Offer a very short reply. 0.59. What is the difference between the highest and the second highest Electricity production(% of total) in Mongolia?
Keep it short and to the point. 0.16. What is the difference between the highest and the second highest Electricity production(% of total) of Russian Federation?
Offer a terse response. 0.84. What is the difference between the highest and the second highest Electricity production(% of total) in Serbia?
Make the answer very short. 1.58. What is the difference between the highest and the lowest Electricity production(% of total) in France?
Your answer should be very brief. 1.97. What is the difference between the highest and the lowest Electricity production(% of total) of Mongolia?
Your answer should be very brief. 0.87. What is the difference between the highest and the lowest Electricity production(% of total) of Russian Federation?
Your response must be concise. 2.68. What is the difference between the highest and the lowest Electricity production(% of total) of Serbia?
Provide a short and direct response. 13.12. 